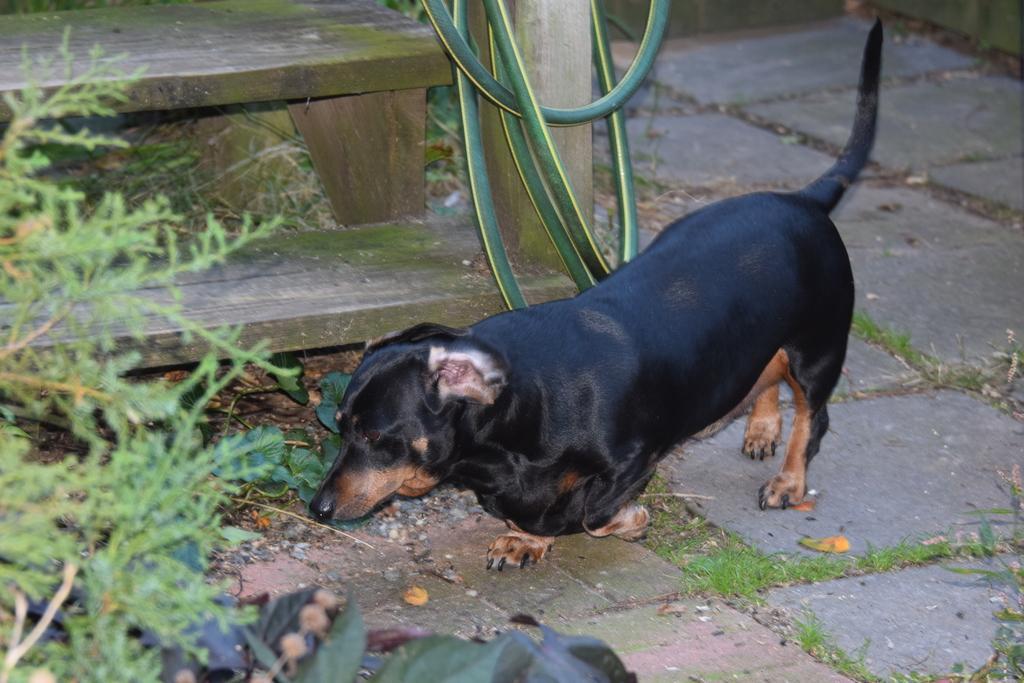Can you describe this image briefly? In this image I can see a dog on the ground. On the left side there are few plants. In the background there is a wooden plank and a pipe. 